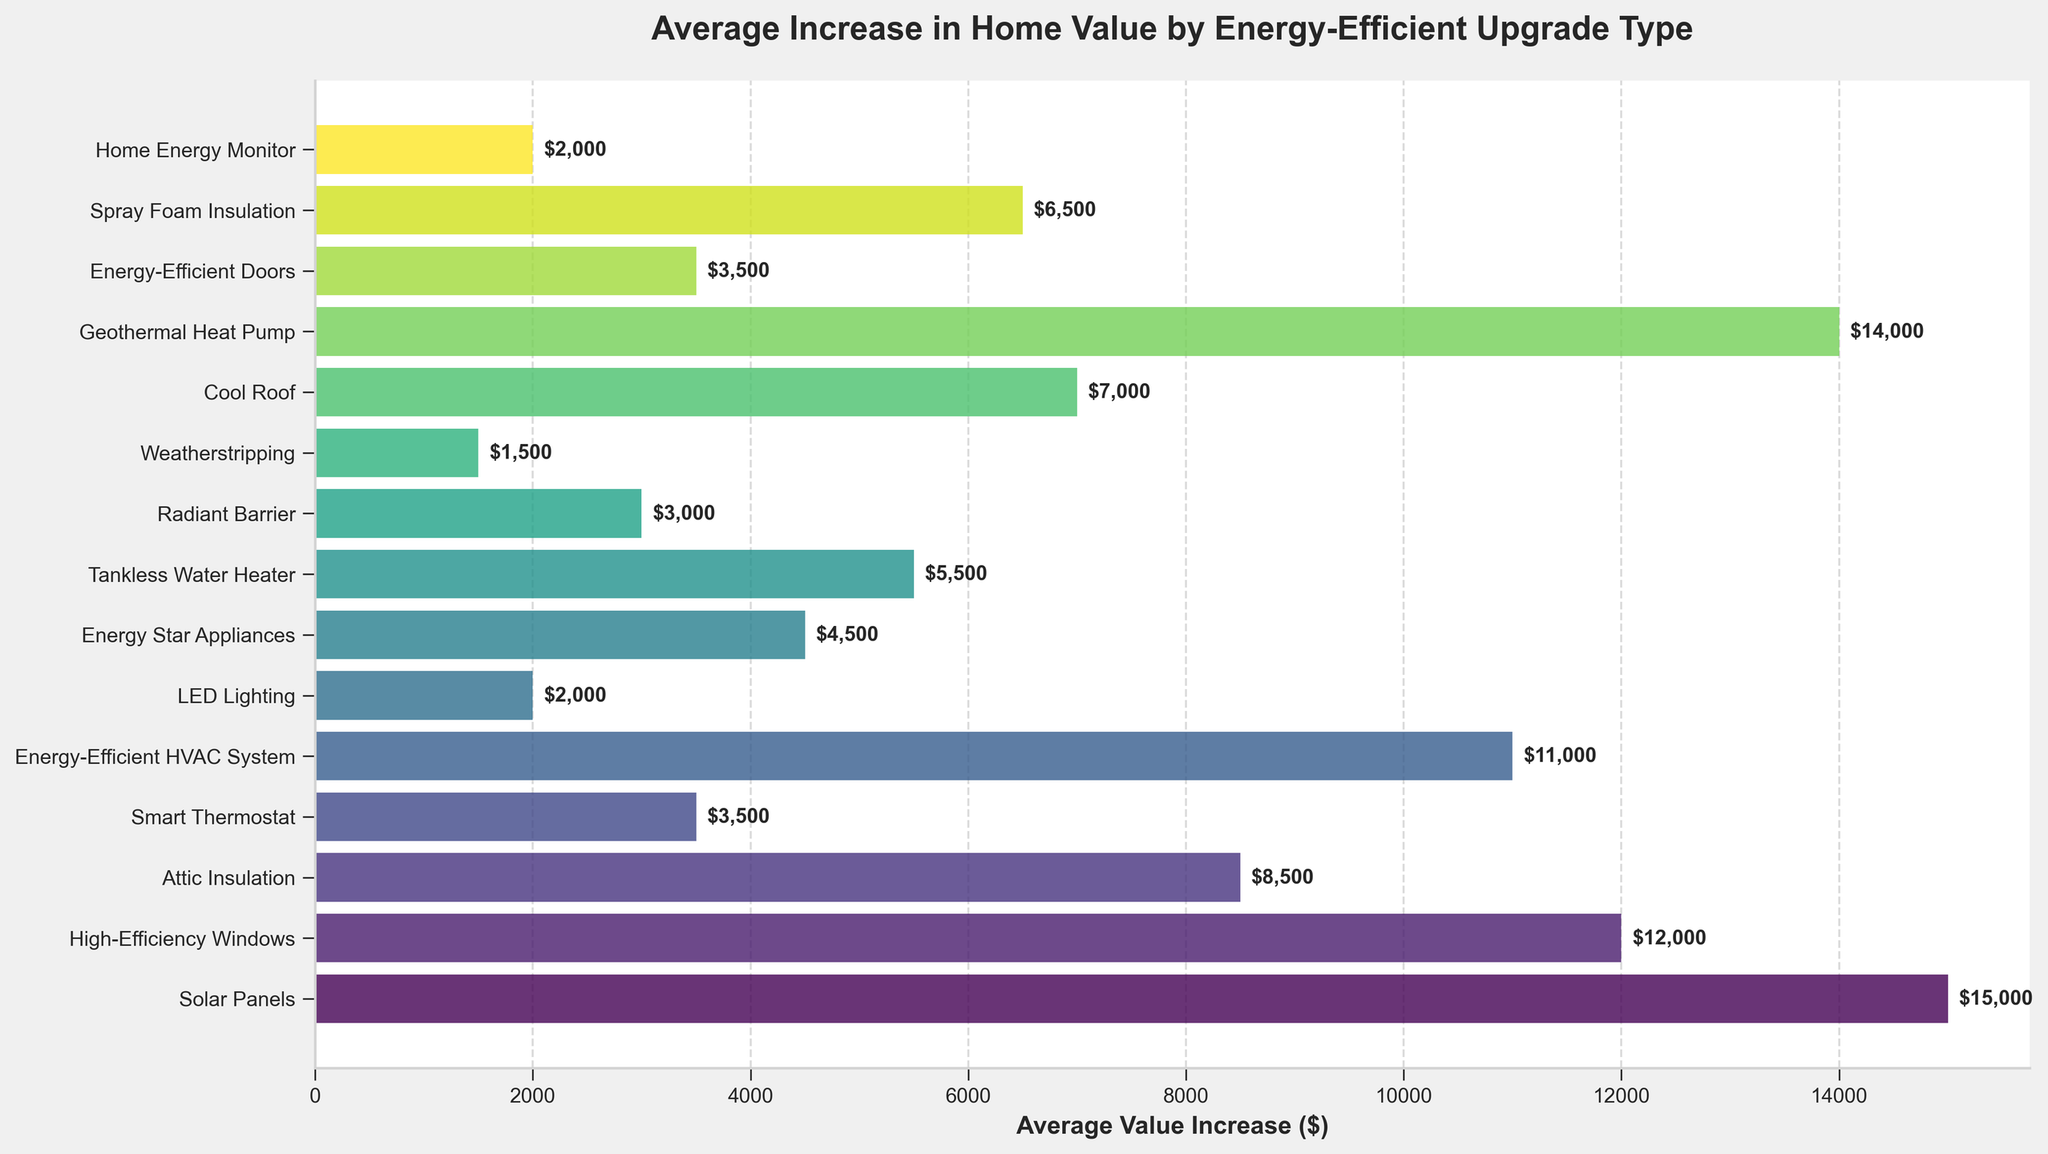What is the average increase in home value for the upgrades that provide more than $10,000 increase? First, identify the upgrades that provide more than a $10,000 increase: Solar Panels ($15,000), High-Efficiency Windows ($12,000), Energy-Efficient HVAC System ($11,000), and Geothermal Heat Pump ($14,000). Next, sum these values: $15,000 + $12,000 + $11,000 + $14,000 = $52,000. Finally, divide by the number of these upgrades (4): $52,000 / 4 = $13,000.
Answer: $13,000 Which upgrades result in a home value increase of under $5,000? Identify the upgrades with an increase less than $5,000: Smart Thermostat ($3,500), LED Lighting ($2,000), Energy Star Appliances ($4,500), Radiant Barrier ($3,000), Weatherstripping ($1,500), and Home Energy Monitor ($2,000).
Answer: Smart Thermostat, LED Lighting, Energy Star Appliances, Radiant Barrier, Weatherstripping, Home Energy Monitor Which upgrade type yields the highest increase in home value? Look at the chart and find the upgrade with the highest bar: Solar Panels with an increase of $15,000.
Answer: Solar Panels How does the increase in home value from attic insulation compare to that from a smart thermostat? Observe the chart to compare the bars for Attic Insulation ($8,500) and Smart Thermostat ($3,500): $8,500 - $3,500 = $5,000.
Answer: $5,000 more Which two upgrades have similar increases in home value and what are those values? Observe the chart for two upgrades with similar values: Smart Thermostat ($3,500) and Energy-Efficient Doors ($3,500). Both have an increase of $3,500.
Answer: Smart Thermostat and Energy-Efficient Doors, $3,500 each What is the combined average value increase from Tankless Water Heater and Cool Roof? First, sum the values of Tankless Water Heater ($5,500) and Cool Roof ($7,000): $5,500 + $7,000 = $12,500. Then divide by 2 (number of upgrades): $12,500 / 2 = $6,250.
Answer: $6,250 How many upgrades increase home value by at least $10,000? Count the number of bars with a value of at least $10,000: Solar Panels ($15,000), High-Efficiency Windows ($12,000), Energy-Efficient HVAC System ($11,000), Geothermal Heat Pump ($14,000). There are four such upgrades.
Answer: Four Which upgrade has a lower value increase: LED Lighting or Weatherstripping? Compare the values for LED Lighting ($2,000) and Weatherstripping ($1,500). Weatherstripping has a lower increase.
Answer: Weatherstripping What is the total increase in home value from the three least beneficial upgrades? Identify the three upgrades with the smallest values: Weatherstripping ($1,500), LED Lighting ($2,000), Home Energy Monitor ($2,000). Sum these values: $1,500 + $2,000 + $2,000 = $5,500.
Answer: $5,500 